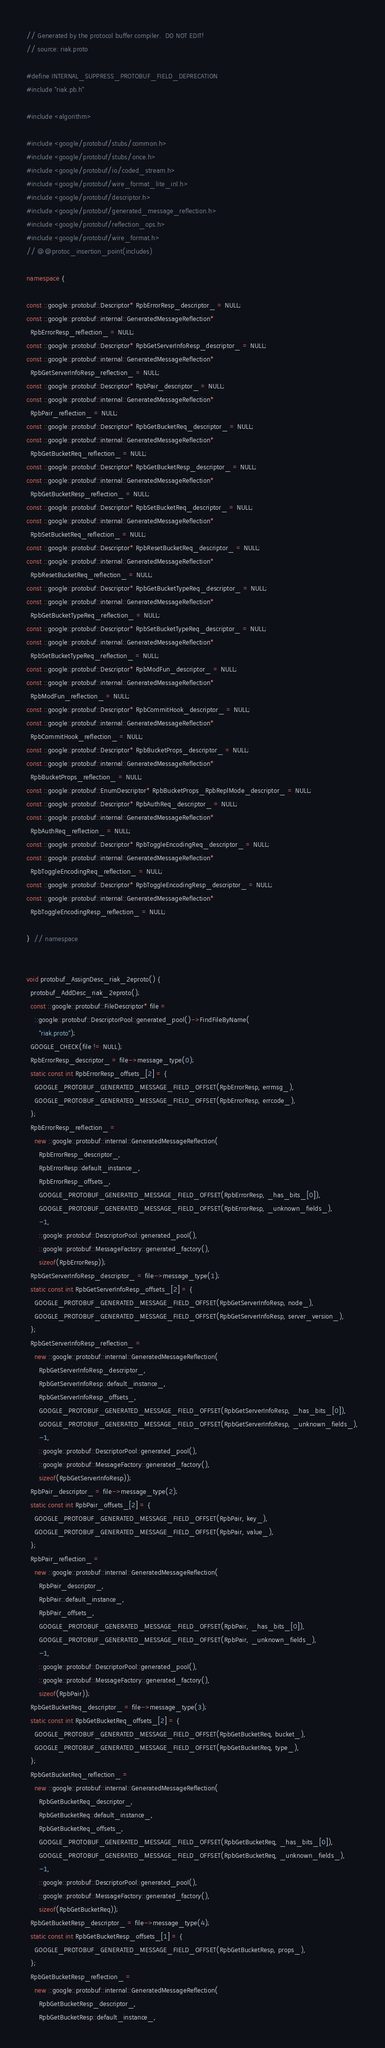Convert code to text. <code><loc_0><loc_0><loc_500><loc_500><_C++_>// Generated by the protocol buffer compiler.  DO NOT EDIT!
// source: riak.proto

#define INTERNAL_SUPPRESS_PROTOBUF_FIELD_DEPRECATION
#include "riak.pb.h"

#include <algorithm>

#include <google/protobuf/stubs/common.h>
#include <google/protobuf/stubs/once.h>
#include <google/protobuf/io/coded_stream.h>
#include <google/protobuf/wire_format_lite_inl.h>
#include <google/protobuf/descriptor.h>
#include <google/protobuf/generated_message_reflection.h>
#include <google/protobuf/reflection_ops.h>
#include <google/protobuf/wire_format.h>
// @@protoc_insertion_point(includes)

namespace {

const ::google::protobuf::Descriptor* RpbErrorResp_descriptor_ = NULL;
const ::google::protobuf::internal::GeneratedMessageReflection*
  RpbErrorResp_reflection_ = NULL;
const ::google::protobuf::Descriptor* RpbGetServerInfoResp_descriptor_ = NULL;
const ::google::protobuf::internal::GeneratedMessageReflection*
  RpbGetServerInfoResp_reflection_ = NULL;
const ::google::protobuf::Descriptor* RpbPair_descriptor_ = NULL;
const ::google::protobuf::internal::GeneratedMessageReflection*
  RpbPair_reflection_ = NULL;
const ::google::protobuf::Descriptor* RpbGetBucketReq_descriptor_ = NULL;
const ::google::protobuf::internal::GeneratedMessageReflection*
  RpbGetBucketReq_reflection_ = NULL;
const ::google::protobuf::Descriptor* RpbGetBucketResp_descriptor_ = NULL;
const ::google::protobuf::internal::GeneratedMessageReflection*
  RpbGetBucketResp_reflection_ = NULL;
const ::google::protobuf::Descriptor* RpbSetBucketReq_descriptor_ = NULL;
const ::google::protobuf::internal::GeneratedMessageReflection*
  RpbSetBucketReq_reflection_ = NULL;
const ::google::protobuf::Descriptor* RpbResetBucketReq_descriptor_ = NULL;
const ::google::protobuf::internal::GeneratedMessageReflection*
  RpbResetBucketReq_reflection_ = NULL;
const ::google::protobuf::Descriptor* RpbGetBucketTypeReq_descriptor_ = NULL;
const ::google::protobuf::internal::GeneratedMessageReflection*
  RpbGetBucketTypeReq_reflection_ = NULL;
const ::google::protobuf::Descriptor* RpbSetBucketTypeReq_descriptor_ = NULL;
const ::google::protobuf::internal::GeneratedMessageReflection*
  RpbSetBucketTypeReq_reflection_ = NULL;
const ::google::protobuf::Descriptor* RpbModFun_descriptor_ = NULL;
const ::google::protobuf::internal::GeneratedMessageReflection*
  RpbModFun_reflection_ = NULL;
const ::google::protobuf::Descriptor* RpbCommitHook_descriptor_ = NULL;
const ::google::protobuf::internal::GeneratedMessageReflection*
  RpbCommitHook_reflection_ = NULL;
const ::google::protobuf::Descriptor* RpbBucketProps_descriptor_ = NULL;
const ::google::protobuf::internal::GeneratedMessageReflection*
  RpbBucketProps_reflection_ = NULL;
const ::google::protobuf::EnumDescriptor* RpbBucketProps_RpbReplMode_descriptor_ = NULL;
const ::google::protobuf::Descriptor* RpbAuthReq_descriptor_ = NULL;
const ::google::protobuf::internal::GeneratedMessageReflection*
  RpbAuthReq_reflection_ = NULL;
const ::google::protobuf::Descriptor* RpbToggleEncodingReq_descriptor_ = NULL;
const ::google::protobuf::internal::GeneratedMessageReflection*
  RpbToggleEncodingReq_reflection_ = NULL;
const ::google::protobuf::Descriptor* RpbToggleEncodingResp_descriptor_ = NULL;
const ::google::protobuf::internal::GeneratedMessageReflection*
  RpbToggleEncodingResp_reflection_ = NULL;

}  // namespace


void protobuf_AssignDesc_riak_2eproto() {
  protobuf_AddDesc_riak_2eproto();
  const ::google::protobuf::FileDescriptor* file =
    ::google::protobuf::DescriptorPool::generated_pool()->FindFileByName(
      "riak.proto");
  GOOGLE_CHECK(file != NULL);
  RpbErrorResp_descriptor_ = file->message_type(0);
  static const int RpbErrorResp_offsets_[2] = {
    GOOGLE_PROTOBUF_GENERATED_MESSAGE_FIELD_OFFSET(RpbErrorResp, errmsg_),
    GOOGLE_PROTOBUF_GENERATED_MESSAGE_FIELD_OFFSET(RpbErrorResp, errcode_),
  };
  RpbErrorResp_reflection_ =
    new ::google::protobuf::internal::GeneratedMessageReflection(
      RpbErrorResp_descriptor_,
      RpbErrorResp::default_instance_,
      RpbErrorResp_offsets_,
      GOOGLE_PROTOBUF_GENERATED_MESSAGE_FIELD_OFFSET(RpbErrorResp, _has_bits_[0]),
      GOOGLE_PROTOBUF_GENERATED_MESSAGE_FIELD_OFFSET(RpbErrorResp, _unknown_fields_),
      -1,
      ::google::protobuf::DescriptorPool::generated_pool(),
      ::google::protobuf::MessageFactory::generated_factory(),
      sizeof(RpbErrorResp));
  RpbGetServerInfoResp_descriptor_ = file->message_type(1);
  static const int RpbGetServerInfoResp_offsets_[2] = {
    GOOGLE_PROTOBUF_GENERATED_MESSAGE_FIELD_OFFSET(RpbGetServerInfoResp, node_),
    GOOGLE_PROTOBUF_GENERATED_MESSAGE_FIELD_OFFSET(RpbGetServerInfoResp, server_version_),
  };
  RpbGetServerInfoResp_reflection_ =
    new ::google::protobuf::internal::GeneratedMessageReflection(
      RpbGetServerInfoResp_descriptor_,
      RpbGetServerInfoResp::default_instance_,
      RpbGetServerInfoResp_offsets_,
      GOOGLE_PROTOBUF_GENERATED_MESSAGE_FIELD_OFFSET(RpbGetServerInfoResp, _has_bits_[0]),
      GOOGLE_PROTOBUF_GENERATED_MESSAGE_FIELD_OFFSET(RpbGetServerInfoResp, _unknown_fields_),
      -1,
      ::google::protobuf::DescriptorPool::generated_pool(),
      ::google::protobuf::MessageFactory::generated_factory(),
      sizeof(RpbGetServerInfoResp));
  RpbPair_descriptor_ = file->message_type(2);
  static const int RpbPair_offsets_[2] = {
    GOOGLE_PROTOBUF_GENERATED_MESSAGE_FIELD_OFFSET(RpbPair, key_),
    GOOGLE_PROTOBUF_GENERATED_MESSAGE_FIELD_OFFSET(RpbPair, value_),
  };
  RpbPair_reflection_ =
    new ::google::protobuf::internal::GeneratedMessageReflection(
      RpbPair_descriptor_,
      RpbPair::default_instance_,
      RpbPair_offsets_,
      GOOGLE_PROTOBUF_GENERATED_MESSAGE_FIELD_OFFSET(RpbPair, _has_bits_[0]),
      GOOGLE_PROTOBUF_GENERATED_MESSAGE_FIELD_OFFSET(RpbPair, _unknown_fields_),
      -1,
      ::google::protobuf::DescriptorPool::generated_pool(),
      ::google::protobuf::MessageFactory::generated_factory(),
      sizeof(RpbPair));
  RpbGetBucketReq_descriptor_ = file->message_type(3);
  static const int RpbGetBucketReq_offsets_[2] = {
    GOOGLE_PROTOBUF_GENERATED_MESSAGE_FIELD_OFFSET(RpbGetBucketReq, bucket_),
    GOOGLE_PROTOBUF_GENERATED_MESSAGE_FIELD_OFFSET(RpbGetBucketReq, type_),
  };
  RpbGetBucketReq_reflection_ =
    new ::google::protobuf::internal::GeneratedMessageReflection(
      RpbGetBucketReq_descriptor_,
      RpbGetBucketReq::default_instance_,
      RpbGetBucketReq_offsets_,
      GOOGLE_PROTOBUF_GENERATED_MESSAGE_FIELD_OFFSET(RpbGetBucketReq, _has_bits_[0]),
      GOOGLE_PROTOBUF_GENERATED_MESSAGE_FIELD_OFFSET(RpbGetBucketReq, _unknown_fields_),
      -1,
      ::google::protobuf::DescriptorPool::generated_pool(),
      ::google::protobuf::MessageFactory::generated_factory(),
      sizeof(RpbGetBucketReq));
  RpbGetBucketResp_descriptor_ = file->message_type(4);
  static const int RpbGetBucketResp_offsets_[1] = {
    GOOGLE_PROTOBUF_GENERATED_MESSAGE_FIELD_OFFSET(RpbGetBucketResp, props_),
  };
  RpbGetBucketResp_reflection_ =
    new ::google::protobuf::internal::GeneratedMessageReflection(
      RpbGetBucketResp_descriptor_,
      RpbGetBucketResp::default_instance_,</code> 